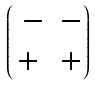Convert formula to latex. <formula><loc_0><loc_0><loc_500><loc_500>\begin{pmatrix} \ - & - \\ + & + \end{pmatrix}</formula> 